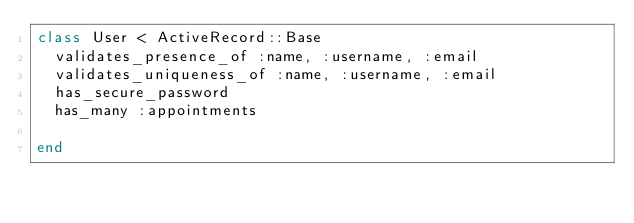<code> <loc_0><loc_0><loc_500><loc_500><_Ruby_>class User < ActiveRecord::Base
  validates_presence_of :name, :username, :email
  validates_uniqueness_of :name, :username, :email
  has_secure_password
  has_many :appointments

end
</code> 